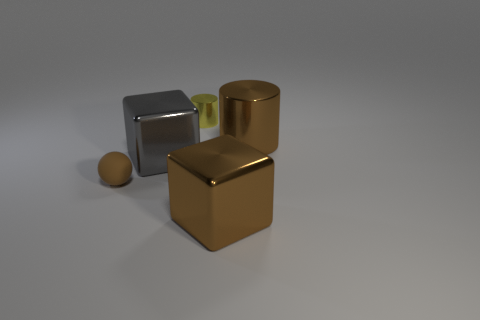Add 4 large brown objects. How many objects exist? 9 Subtract all spheres. How many objects are left? 4 Subtract 0 blue spheres. How many objects are left? 5 Subtract all big brown metal cubes. Subtract all tiny things. How many objects are left? 2 Add 2 brown blocks. How many brown blocks are left? 3 Add 2 small brown metal cylinders. How many small brown metal cylinders exist? 2 